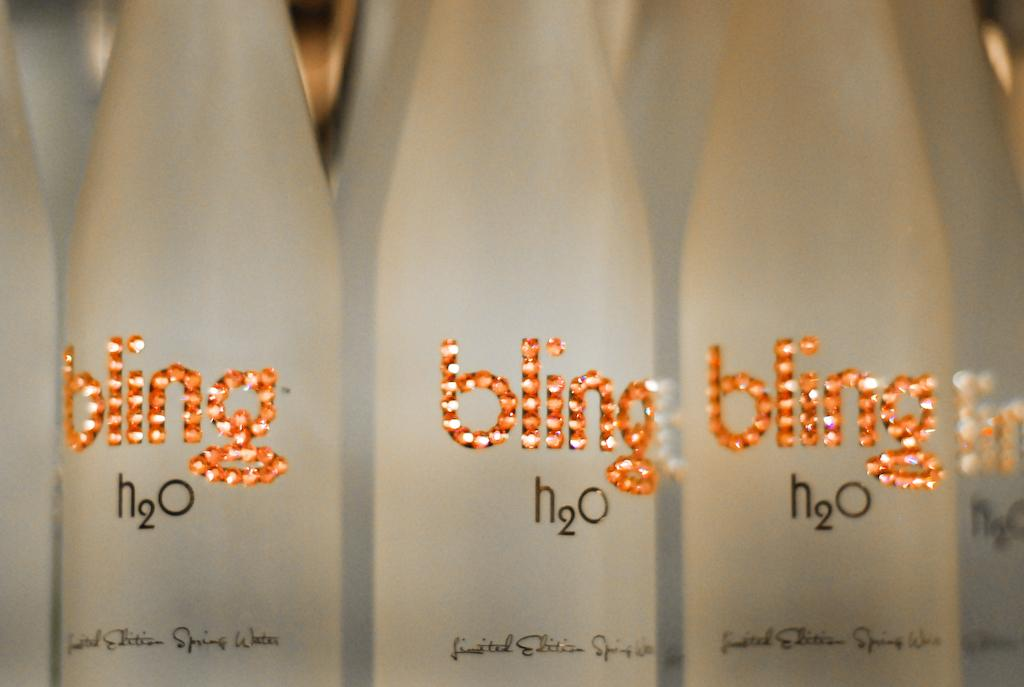<image>
Create a compact narrative representing the image presented. three bottle of water which are labelled bling in diamente letters 